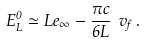<formula> <loc_0><loc_0><loc_500><loc_500>E ^ { 0 } _ { L } \simeq L e _ { \infty } - \frac { \pi c } { 6 L } \ v _ { f } \, .</formula> 